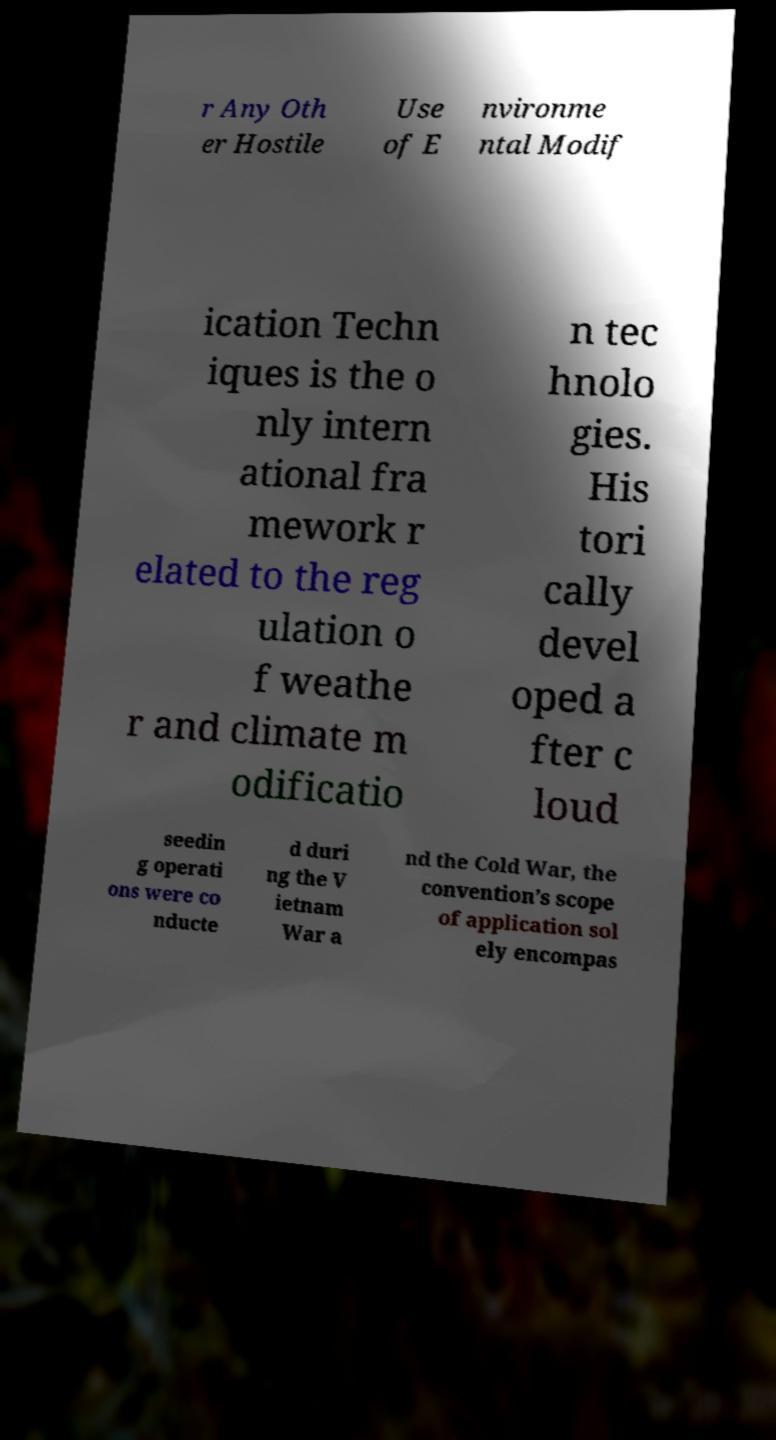Could you assist in decoding the text presented in this image and type it out clearly? r Any Oth er Hostile Use of E nvironme ntal Modif ication Techn iques is the o nly intern ational fra mework r elated to the reg ulation o f weathe r and climate m odificatio n tec hnolo gies. His tori cally devel oped a fter c loud seedin g operati ons were co nducte d duri ng the V ietnam War a nd the Cold War, the convention’s scope of application sol ely encompas 